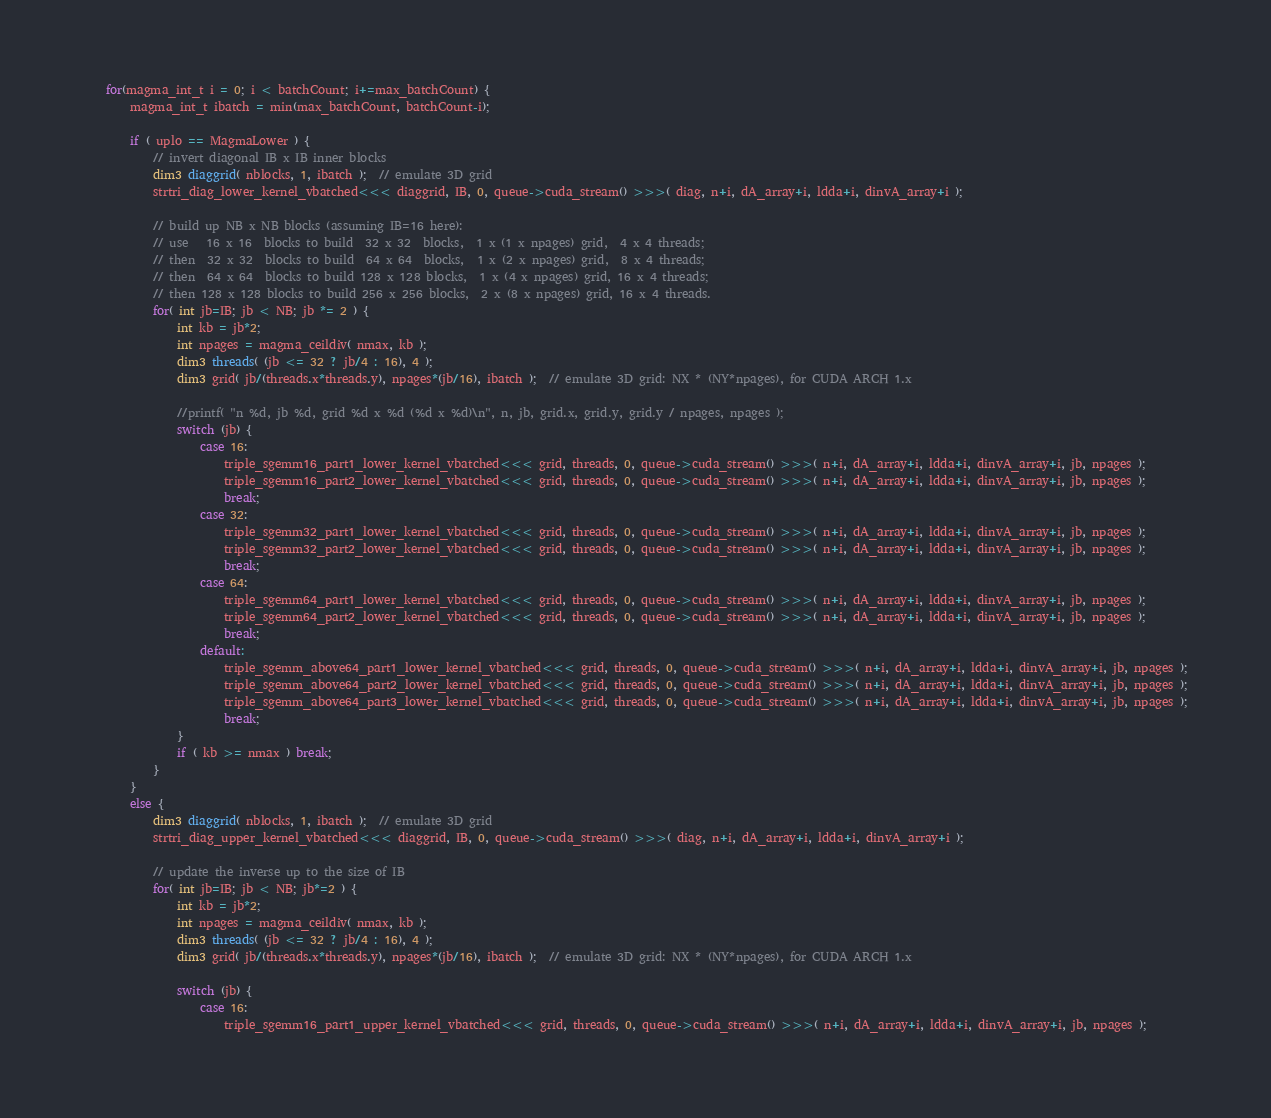<code> <loc_0><loc_0><loc_500><loc_500><_Cuda_>
    for(magma_int_t i = 0; i < batchCount; i+=max_batchCount) {
        magma_int_t ibatch = min(max_batchCount, batchCount-i);

        if ( uplo == MagmaLower ) {
            // invert diagonal IB x IB inner blocks
            dim3 diaggrid( nblocks, 1, ibatch );  // emulate 3D grid
            strtri_diag_lower_kernel_vbatched<<< diaggrid, IB, 0, queue->cuda_stream() >>>( diag, n+i, dA_array+i, ldda+i, dinvA_array+i );

            // build up NB x NB blocks (assuming IB=16 here):
            // use   16 x 16  blocks to build  32 x 32  blocks,  1 x (1 x npages) grid,  4 x 4 threads;
            // then  32 x 32  blocks to build  64 x 64  blocks,  1 x (2 x npages) grid,  8 x 4 threads;
            // then  64 x 64  blocks to build 128 x 128 blocks,  1 x (4 x npages) grid, 16 x 4 threads;
            // then 128 x 128 blocks to build 256 x 256 blocks,  2 x (8 x npages) grid, 16 x 4 threads.
            for( int jb=IB; jb < NB; jb *= 2 ) {
                int kb = jb*2;
                int npages = magma_ceildiv( nmax, kb );
                dim3 threads( (jb <= 32 ? jb/4 : 16), 4 );
                dim3 grid( jb/(threads.x*threads.y), npages*(jb/16), ibatch );  // emulate 3D grid: NX * (NY*npages), for CUDA ARCH 1.x

                //printf( "n %d, jb %d, grid %d x %d (%d x %d)\n", n, jb, grid.x, grid.y, grid.y / npages, npages );
                switch (jb) {
                    case 16:
                        triple_sgemm16_part1_lower_kernel_vbatched<<< grid, threads, 0, queue->cuda_stream() >>>( n+i, dA_array+i, ldda+i, dinvA_array+i, jb, npages );
                        triple_sgemm16_part2_lower_kernel_vbatched<<< grid, threads, 0, queue->cuda_stream() >>>( n+i, dA_array+i, ldda+i, dinvA_array+i, jb, npages );
                        break;
                    case 32:
                        triple_sgemm32_part1_lower_kernel_vbatched<<< grid, threads, 0, queue->cuda_stream() >>>( n+i, dA_array+i, ldda+i, dinvA_array+i, jb, npages );
                        triple_sgemm32_part2_lower_kernel_vbatched<<< grid, threads, 0, queue->cuda_stream() >>>( n+i, dA_array+i, ldda+i, dinvA_array+i, jb, npages );
                        break;
                    case 64:
                        triple_sgemm64_part1_lower_kernel_vbatched<<< grid, threads, 0, queue->cuda_stream() >>>( n+i, dA_array+i, ldda+i, dinvA_array+i, jb, npages );
                        triple_sgemm64_part2_lower_kernel_vbatched<<< grid, threads, 0, queue->cuda_stream() >>>( n+i, dA_array+i, ldda+i, dinvA_array+i, jb, npages );
                        break;
                    default:
                        triple_sgemm_above64_part1_lower_kernel_vbatched<<< grid, threads, 0, queue->cuda_stream() >>>( n+i, dA_array+i, ldda+i, dinvA_array+i, jb, npages );
                        triple_sgemm_above64_part2_lower_kernel_vbatched<<< grid, threads, 0, queue->cuda_stream() >>>( n+i, dA_array+i, ldda+i, dinvA_array+i, jb, npages );
                        triple_sgemm_above64_part3_lower_kernel_vbatched<<< grid, threads, 0, queue->cuda_stream() >>>( n+i, dA_array+i, ldda+i, dinvA_array+i, jb, npages );
                        break;
                }
                if ( kb >= nmax ) break;
            }
        }
        else {
            dim3 diaggrid( nblocks, 1, ibatch );  // emulate 3D grid
            strtri_diag_upper_kernel_vbatched<<< diaggrid, IB, 0, queue->cuda_stream() >>>( diag, n+i, dA_array+i, ldda+i, dinvA_array+i );

            // update the inverse up to the size of IB
            for( int jb=IB; jb < NB; jb*=2 ) {
                int kb = jb*2;
                int npages = magma_ceildiv( nmax, kb );
                dim3 threads( (jb <= 32 ? jb/4 : 16), 4 );
                dim3 grid( jb/(threads.x*threads.y), npages*(jb/16), ibatch );  // emulate 3D grid: NX * (NY*npages), for CUDA ARCH 1.x

                switch (jb) {
                    case 16:
                        triple_sgemm16_part1_upper_kernel_vbatched<<< grid, threads, 0, queue->cuda_stream() >>>( n+i, dA_array+i, ldda+i, dinvA_array+i, jb, npages );</code> 